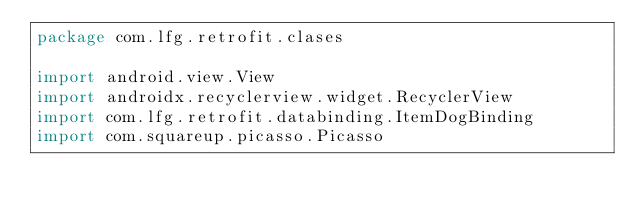Convert code to text. <code><loc_0><loc_0><loc_500><loc_500><_Kotlin_>package com.lfg.retrofit.clases

import android.view.View
import androidx.recyclerview.widget.RecyclerView
import com.lfg.retrofit.databinding.ItemDogBinding
import com.squareup.picasso.Picasso
</code> 